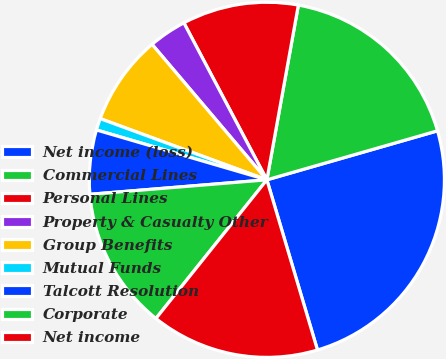Convert chart to OTSL. <chart><loc_0><loc_0><loc_500><loc_500><pie_chart><fcel>Net income (loss)<fcel>Commercial Lines<fcel>Personal Lines<fcel>Property & Casualty Other<fcel>Group Benefits<fcel>Mutual Funds<fcel>Talcott Resolution<fcel>Corporate<fcel>Net income<nl><fcel>24.85%<fcel>17.71%<fcel>10.58%<fcel>3.45%<fcel>8.21%<fcel>1.07%<fcel>5.83%<fcel>12.96%<fcel>15.34%<nl></chart> 